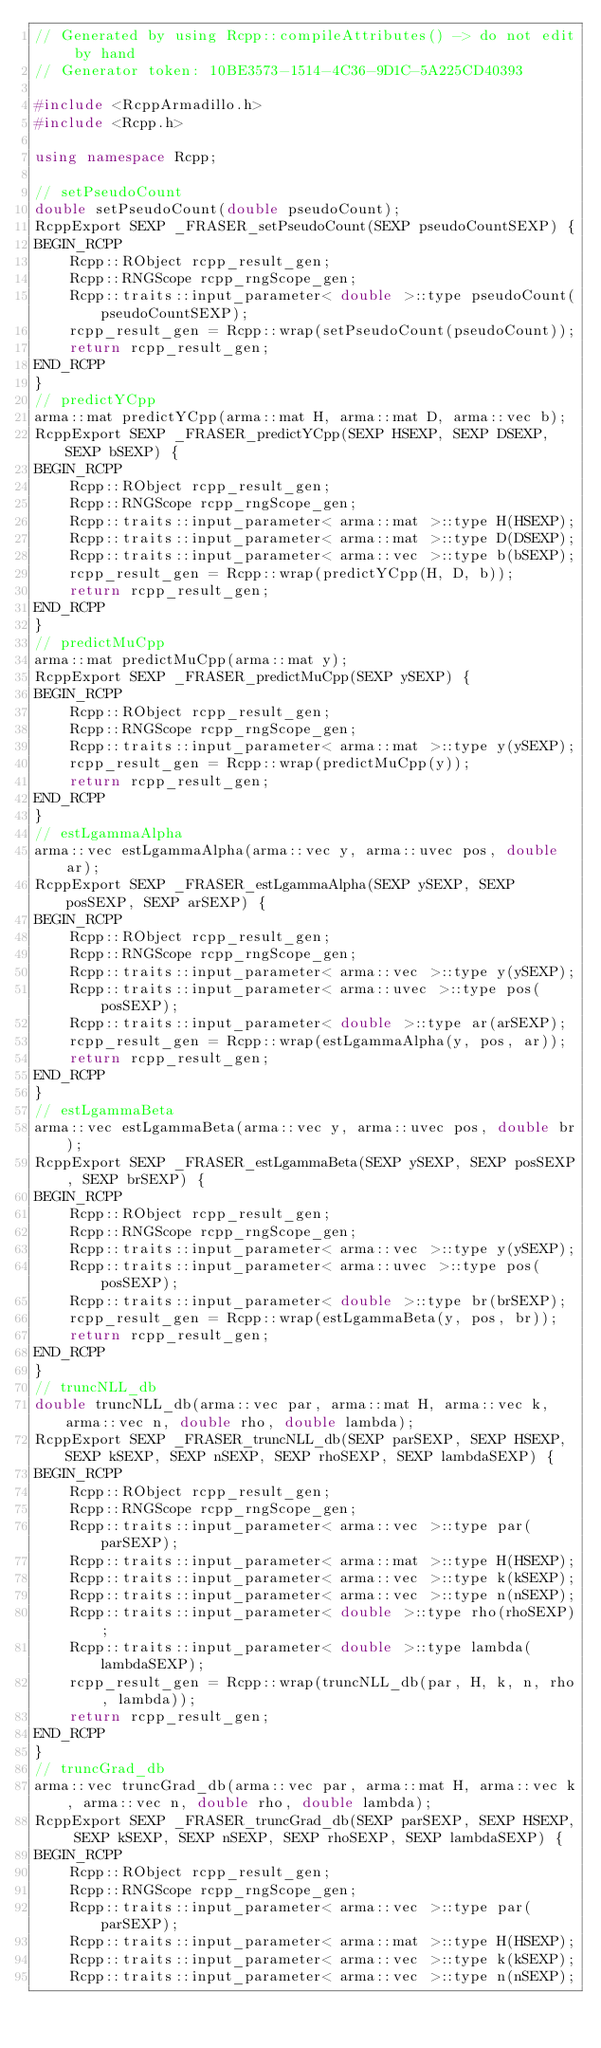<code> <loc_0><loc_0><loc_500><loc_500><_C++_>// Generated by using Rcpp::compileAttributes() -> do not edit by hand
// Generator token: 10BE3573-1514-4C36-9D1C-5A225CD40393

#include <RcppArmadillo.h>
#include <Rcpp.h>

using namespace Rcpp;

// setPseudoCount
double setPseudoCount(double pseudoCount);
RcppExport SEXP _FRASER_setPseudoCount(SEXP pseudoCountSEXP) {
BEGIN_RCPP
    Rcpp::RObject rcpp_result_gen;
    Rcpp::RNGScope rcpp_rngScope_gen;
    Rcpp::traits::input_parameter< double >::type pseudoCount(pseudoCountSEXP);
    rcpp_result_gen = Rcpp::wrap(setPseudoCount(pseudoCount));
    return rcpp_result_gen;
END_RCPP
}
// predictYCpp
arma::mat predictYCpp(arma::mat H, arma::mat D, arma::vec b);
RcppExport SEXP _FRASER_predictYCpp(SEXP HSEXP, SEXP DSEXP, SEXP bSEXP) {
BEGIN_RCPP
    Rcpp::RObject rcpp_result_gen;
    Rcpp::RNGScope rcpp_rngScope_gen;
    Rcpp::traits::input_parameter< arma::mat >::type H(HSEXP);
    Rcpp::traits::input_parameter< arma::mat >::type D(DSEXP);
    Rcpp::traits::input_parameter< arma::vec >::type b(bSEXP);
    rcpp_result_gen = Rcpp::wrap(predictYCpp(H, D, b));
    return rcpp_result_gen;
END_RCPP
}
// predictMuCpp
arma::mat predictMuCpp(arma::mat y);
RcppExport SEXP _FRASER_predictMuCpp(SEXP ySEXP) {
BEGIN_RCPP
    Rcpp::RObject rcpp_result_gen;
    Rcpp::RNGScope rcpp_rngScope_gen;
    Rcpp::traits::input_parameter< arma::mat >::type y(ySEXP);
    rcpp_result_gen = Rcpp::wrap(predictMuCpp(y));
    return rcpp_result_gen;
END_RCPP
}
// estLgammaAlpha
arma::vec estLgammaAlpha(arma::vec y, arma::uvec pos, double ar);
RcppExport SEXP _FRASER_estLgammaAlpha(SEXP ySEXP, SEXP posSEXP, SEXP arSEXP) {
BEGIN_RCPP
    Rcpp::RObject rcpp_result_gen;
    Rcpp::RNGScope rcpp_rngScope_gen;
    Rcpp::traits::input_parameter< arma::vec >::type y(ySEXP);
    Rcpp::traits::input_parameter< arma::uvec >::type pos(posSEXP);
    Rcpp::traits::input_parameter< double >::type ar(arSEXP);
    rcpp_result_gen = Rcpp::wrap(estLgammaAlpha(y, pos, ar));
    return rcpp_result_gen;
END_RCPP
}
// estLgammaBeta
arma::vec estLgammaBeta(arma::vec y, arma::uvec pos, double br);
RcppExport SEXP _FRASER_estLgammaBeta(SEXP ySEXP, SEXP posSEXP, SEXP brSEXP) {
BEGIN_RCPP
    Rcpp::RObject rcpp_result_gen;
    Rcpp::RNGScope rcpp_rngScope_gen;
    Rcpp::traits::input_parameter< arma::vec >::type y(ySEXP);
    Rcpp::traits::input_parameter< arma::uvec >::type pos(posSEXP);
    Rcpp::traits::input_parameter< double >::type br(brSEXP);
    rcpp_result_gen = Rcpp::wrap(estLgammaBeta(y, pos, br));
    return rcpp_result_gen;
END_RCPP
}
// truncNLL_db
double truncNLL_db(arma::vec par, arma::mat H, arma::vec k, arma::vec n, double rho, double lambda);
RcppExport SEXP _FRASER_truncNLL_db(SEXP parSEXP, SEXP HSEXP, SEXP kSEXP, SEXP nSEXP, SEXP rhoSEXP, SEXP lambdaSEXP) {
BEGIN_RCPP
    Rcpp::RObject rcpp_result_gen;
    Rcpp::RNGScope rcpp_rngScope_gen;
    Rcpp::traits::input_parameter< arma::vec >::type par(parSEXP);
    Rcpp::traits::input_parameter< arma::mat >::type H(HSEXP);
    Rcpp::traits::input_parameter< arma::vec >::type k(kSEXP);
    Rcpp::traits::input_parameter< arma::vec >::type n(nSEXP);
    Rcpp::traits::input_parameter< double >::type rho(rhoSEXP);
    Rcpp::traits::input_parameter< double >::type lambda(lambdaSEXP);
    rcpp_result_gen = Rcpp::wrap(truncNLL_db(par, H, k, n, rho, lambda));
    return rcpp_result_gen;
END_RCPP
}
// truncGrad_db
arma::vec truncGrad_db(arma::vec par, arma::mat H, arma::vec k, arma::vec n, double rho, double lambda);
RcppExport SEXP _FRASER_truncGrad_db(SEXP parSEXP, SEXP HSEXP, SEXP kSEXP, SEXP nSEXP, SEXP rhoSEXP, SEXP lambdaSEXP) {
BEGIN_RCPP
    Rcpp::RObject rcpp_result_gen;
    Rcpp::RNGScope rcpp_rngScope_gen;
    Rcpp::traits::input_parameter< arma::vec >::type par(parSEXP);
    Rcpp::traits::input_parameter< arma::mat >::type H(HSEXP);
    Rcpp::traits::input_parameter< arma::vec >::type k(kSEXP);
    Rcpp::traits::input_parameter< arma::vec >::type n(nSEXP);</code> 